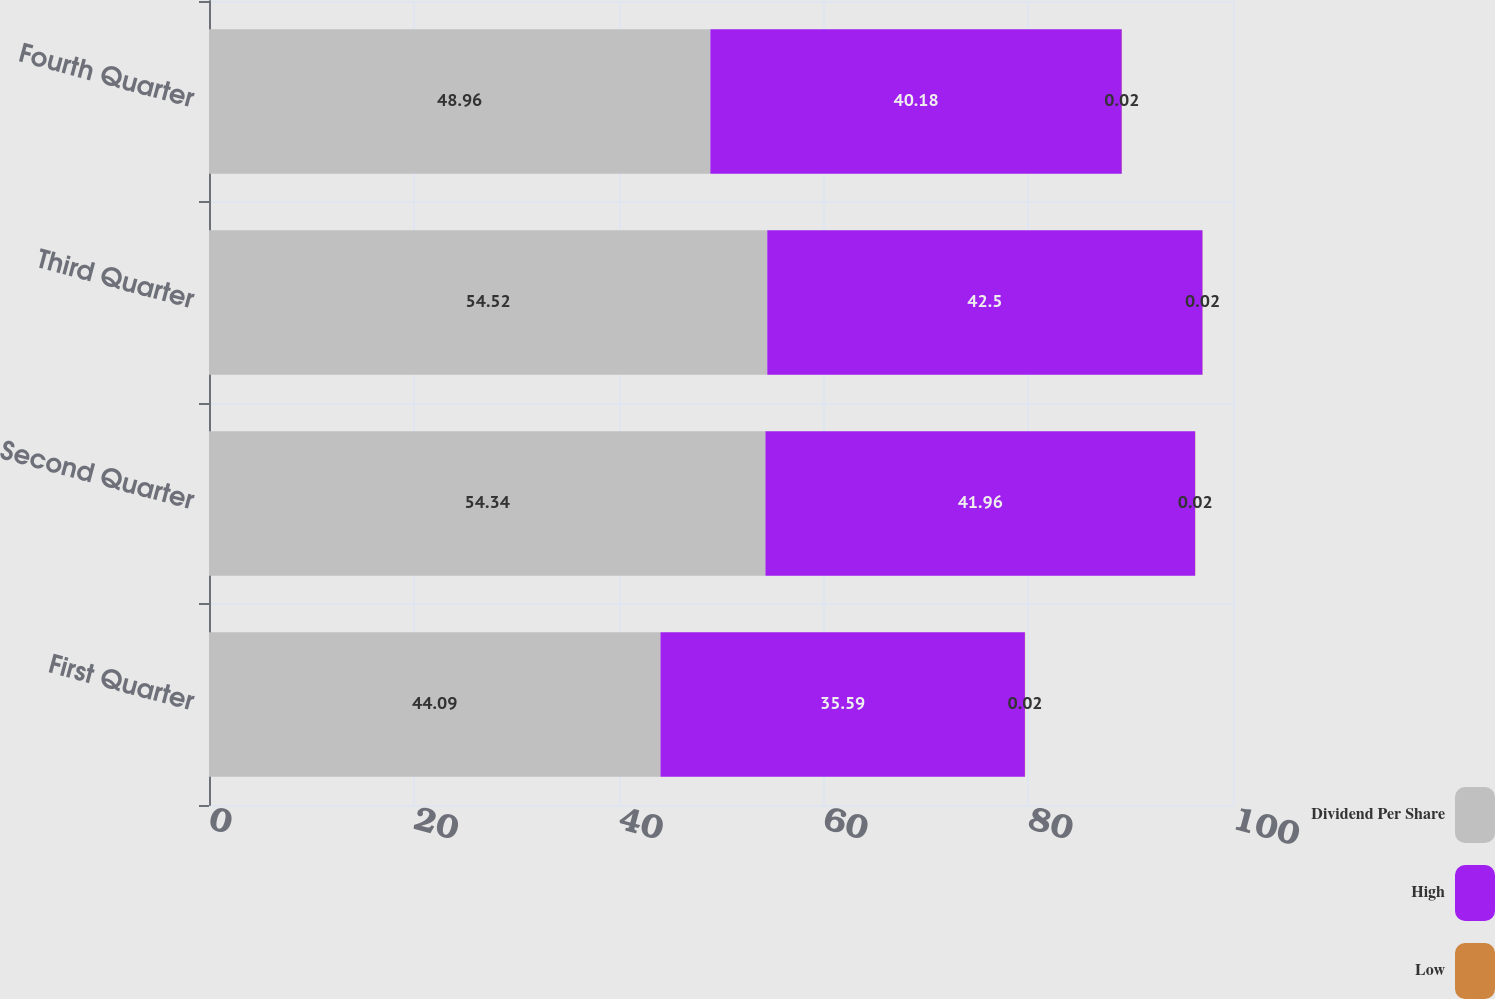Convert chart to OTSL. <chart><loc_0><loc_0><loc_500><loc_500><stacked_bar_chart><ecel><fcel>First Quarter<fcel>Second Quarter<fcel>Third Quarter<fcel>Fourth Quarter<nl><fcel>Dividend Per Share<fcel>44.09<fcel>54.34<fcel>54.52<fcel>48.96<nl><fcel>High<fcel>35.59<fcel>41.96<fcel>42.5<fcel>40.18<nl><fcel>Low<fcel>0.02<fcel>0.02<fcel>0.02<fcel>0.02<nl></chart> 